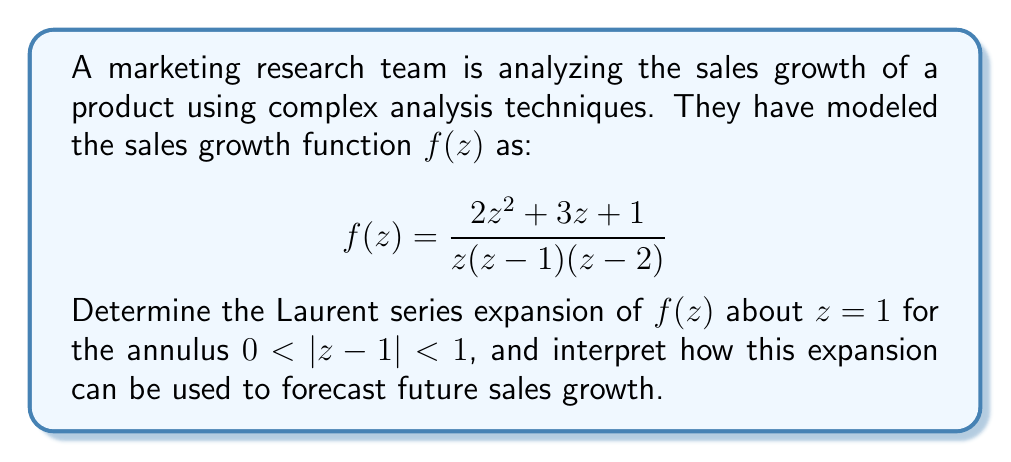Show me your answer to this math problem. To find the Laurent series expansion of $f(z)$ about $z=1$, we need to follow these steps:

1) First, let's rewrite $f(z)$ in partial fractions:

   $$f(z) = \frac{A}{z} + \frac{B}{z-1} + \frac{C}{z-2}$$

2) Solving for A, B, and C:
   
   $$2z^2 + 3z + 1 = A(z-1)(z-2) + Bz(z-2) + Cz(z-1)$$
   
   Comparing coefficients and solving the system of equations, we get:
   
   $A = 1$, $B = -4$, $C = 3$

3) So, our function becomes:

   $$f(z) = \frac{1}{z} - \frac{4}{z-1} + \frac{3}{z-2}$$

4) Now, we need to expand each term about $z=1$:

   For $\frac{1}{z}$:
   $$\frac{1}{z} = \frac{1}{(z-1)+1} = \frac{1}{1+(z-1)} = 1 - (z-1) + (z-1)^2 - (z-1)^3 + ...$$

   For $\frac{4}{z-1}$:
   $$\frac{4}{z-1} = -4\left(\frac{1}{z-1}\right)$$

   For $\frac{3}{z-2}$:
   $$\frac{3}{z-2} = \frac{3}{1+(z-1)} = 3 - 3(z-1) + 3(z-1)^2 - 3(z-1)^3 + ...$$

5) Combining these expansions:

   $$f(z) = [1 - (z-1) + (z-1)^2 - (z-1)^3 + ...] + \frac{4}{1-z} + [3 - 3(z-1) + 3(z-1)^2 - 3(z-1)^3 + ...]$$

6) The Laurent series expansion is:

   $$f(z) = \frac{4}{z-1} + 4 - 4(z-1) + 4(z-1)^2 - 4(z-1)^3 + ...$$

Interpretation for sales growth forecasting:
The Laurent series expansion provides valuable insights for forecasting sales growth:

1) The term $\frac{4}{z-1}$ represents the principal part of the Laurent series, indicating a singularity at $z=1$. This suggests a critical point in the sales growth pattern.

2) The constant term 4 represents the baseline growth rate.

3) The subsequent terms with increasing powers of $(z-1)$ represent deviations from the baseline growth, with alternating signs suggesting oscillatory behavior.

4) The coefficients of these terms (4, -4, 4, -4, ...) indicate the magnitude of these oscillations, which seem to maintain a consistent amplitude.

By analyzing these components, marketers can:
- Identify the baseline growth rate
- Recognize potential cyclical patterns in sales growth
- Anticipate the magnitude of fluctuations around the baseline
- Prepare for potential critical points or significant changes in growth patterns

This information can be crucial for making informed decisions about marketing strategies, inventory management, and resource allocation.
Answer: The Laurent series expansion of $f(z)$ about $z=1$ for $0 < |z-1| < 1$ is:

$$f(z) = \frac{4}{z-1} + 4 - 4(z-1) + 4(z-1)^2 - 4(z-1)^3 + ...$$

This expansion can be used to forecast sales growth by analyzing the baseline growth rate (4), identifying cyclical patterns, anticipating the magnitude of fluctuations, and preparing for critical points in the growth pattern. 